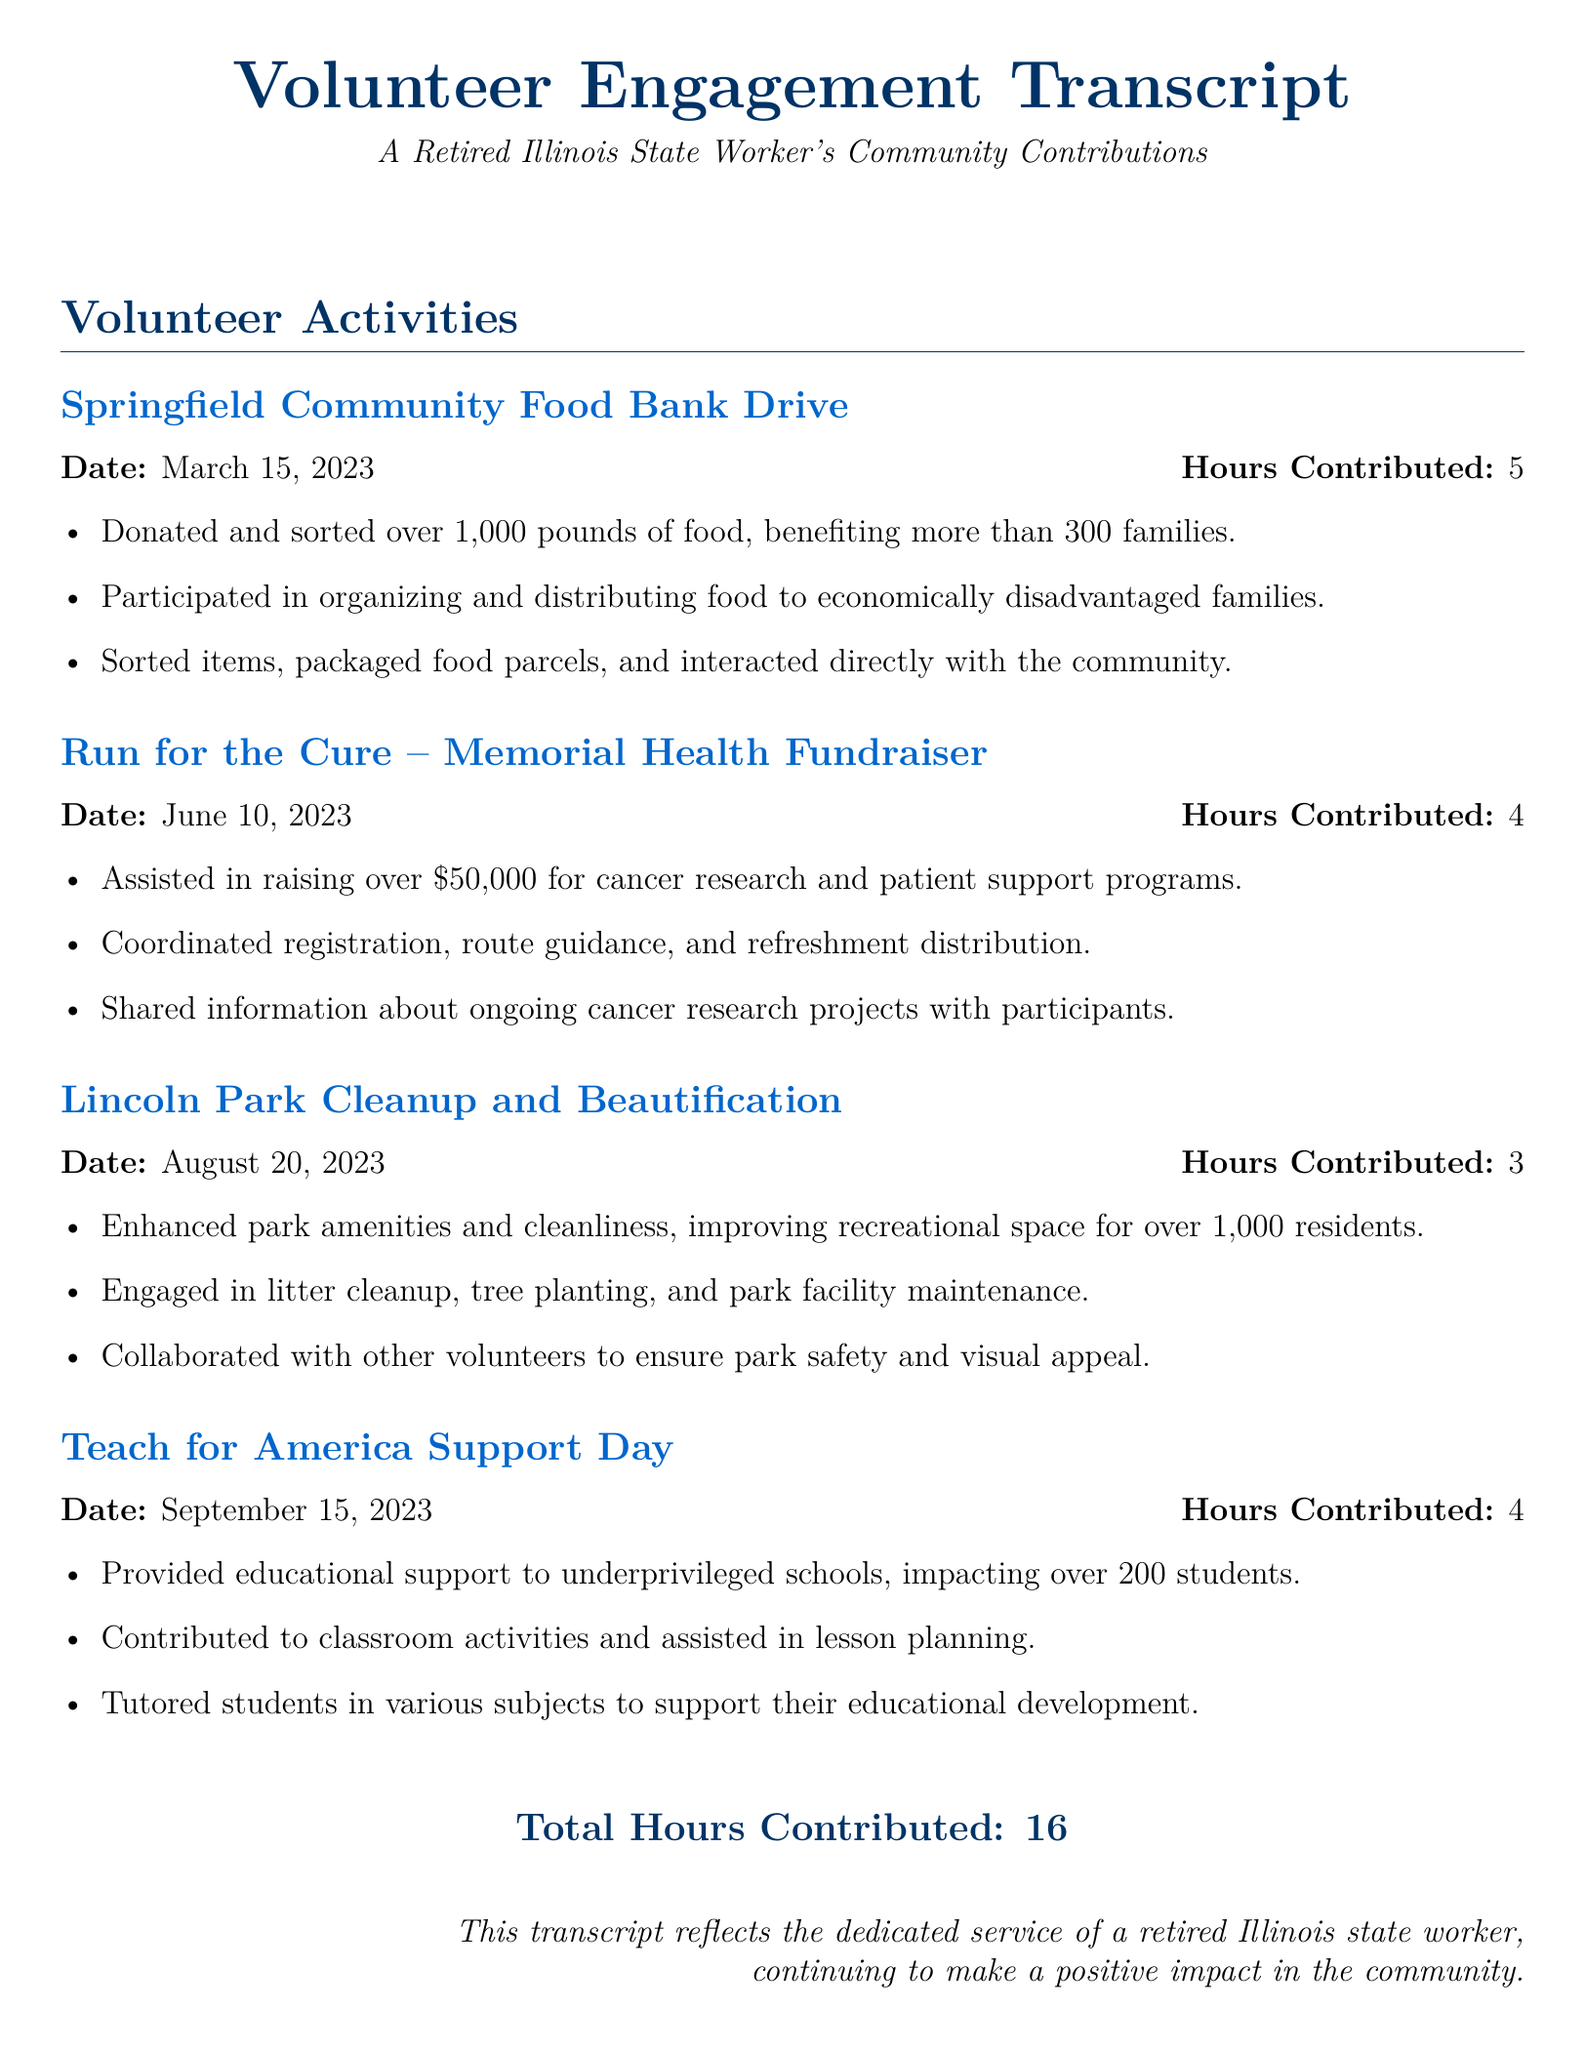What is the date of the Springfield Community Food Bank Drive? The document states that the event took place on March 15, 2023.
Answer: March 15, 2023 How many hours were contributed to the Lincoln Park Cleanup and Beautification? According to the document, 3 hours were contributed to this activity.
Answer: 3 What was the total amount raised during the Run for the Cure? The document mentions that over $50,000 was raised for cancer research and patient support programs.
Answer: Over $50,000 How many families benefited from the Springfield Community Food Bank Drive? The document states that more than 300 families benefited from this event.
Answer: More than 300 What is the total number of hours contributed across all activities? The total hours contributed are summarized in the document as 16.
Answer: 16 Which organization was supported during the Teach for America Support Day? The document specifies that the support was provided to underprivileged schools.
Answer: Underprivileged schools What was a key activity during the Lincoln Park Cleanup and Beautification? The document highlights litter cleanup as one of the activities undertaken during this event.
Answer: Litter cleanup How many students were impacted by the Teach for America Support Day? According to the document, over 200 students were impacted by this initiative.
Answer: Over 200 students 